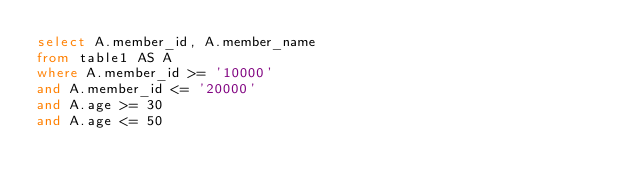<code> <loc_0><loc_0><loc_500><loc_500><_SQL_>select A.member_id, A.member_name
from table1 AS A
where A.member_id >= '10000'
and A.member_id <= '20000'
and A.age >= 30
and A.age <= 50</code> 